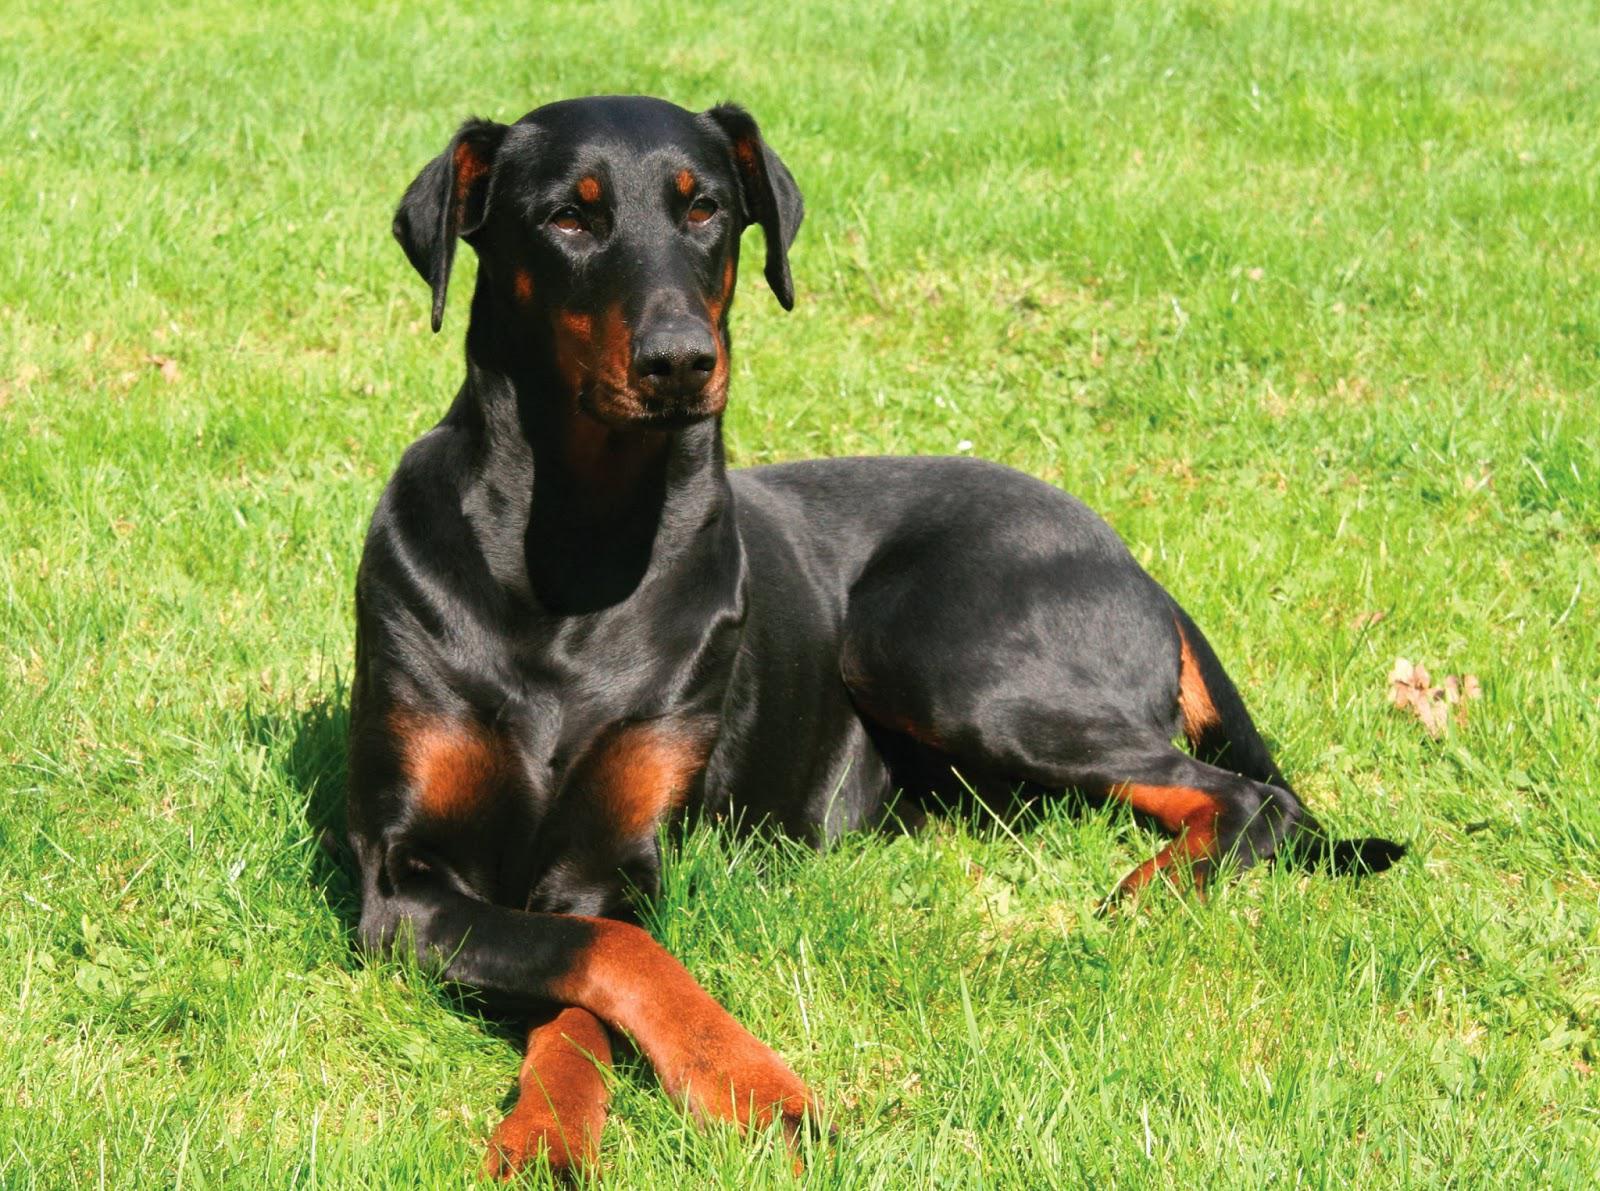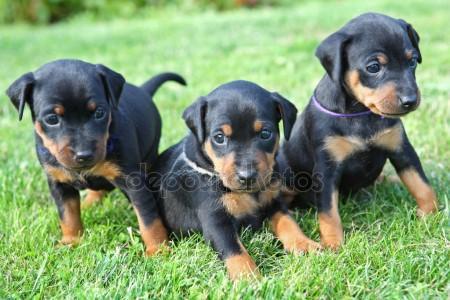The first image is the image on the left, the second image is the image on the right. Evaluate the accuracy of this statement regarding the images: "A total of three pointy-eared black-and-tan dobermans are shown, with at least one staring directly at the camera, and at least one gazing rightward.". Is it true? Answer yes or no. No. The first image is the image on the left, the second image is the image on the right. For the images displayed, is the sentence "The right image contains exactly two dogs." factually correct? Answer yes or no. No. 